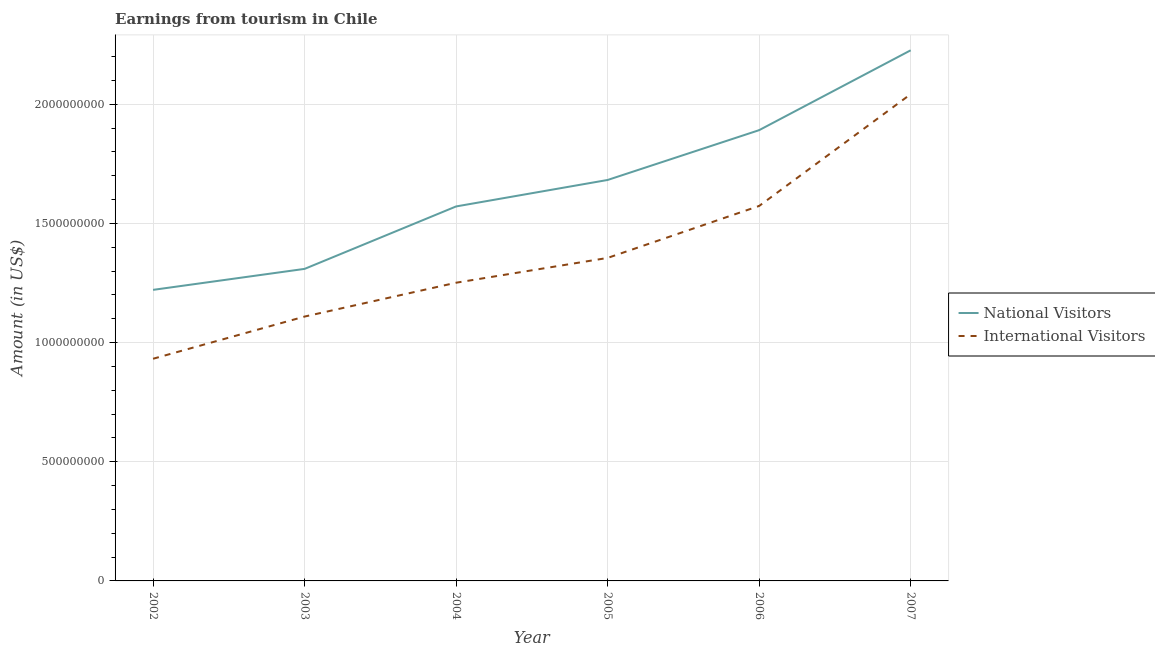Is the number of lines equal to the number of legend labels?
Your answer should be compact. Yes. What is the amount earned from national visitors in 2006?
Ensure brevity in your answer.  1.89e+09. Across all years, what is the maximum amount earned from international visitors?
Keep it short and to the point. 2.04e+09. Across all years, what is the minimum amount earned from national visitors?
Your response must be concise. 1.22e+09. In which year was the amount earned from national visitors minimum?
Make the answer very short. 2002. What is the total amount earned from international visitors in the graph?
Provide a succinct answer. 8.26e+09. What is the difference between the amount earned from national visitors in 2004 and that in 2005?
Offer a terse response. -1.11e+08. What is the difference between the amount earned from national visitors in 2006 and the amount earned from international visitors in 2005?
Provide a short and direct response. 5.36e+08. What is the average amount earned from international visitors per year?
Keep it short and to the point. 1.38e+09. In the year 2005, what is the difference between the amount earned from national visitors and amount earned from international visitors?
Your response must be concise. 3.27e+08. In how many years, is the amount earned from national visitors greater than 300000000 US$?
Make the answer very short. 6. What is the ratio of the amount earned from national visitors in 2002 to that in 2003?
Offer a very short reply. 0.93. What is the difference between the highest and the second highest amount earned from national visitors?
Your response must be concise. 3.35e+08. What is the difference between the highest and the lowest amount earned from international visitors?
Give a very brief answer. 1.11e+09. In how many years, is the amount earned from national visitors greater than the average amount earned from national visitors taken over all years?
Offer a very short reply. 3. How many years are there in the graph?
Provide a short and direct response. 6. Does the graph contain any zero values?
Give a very brief answer. No. What is the title of the graph?
Offer a terse response. Earnings from tourism in Chile. What is the Amount (in US$) in National Visitors in 2002?
Keep it short and to the point. 1.22e+09. What is the Amount (in US$) in International Visitors in 2002?
Offer a terse response. 9.32e+08. What is the Amount (in US$) of National Visitors in 2003?
Keep it short and to the point. 1.31e+09. What is the Amount (in US$) in International Visitors in 2003?
Offer a very short reply. 1.11e+09. What is the Amount (in US$) in National Visitors in 2004?
Ensure brevity in your answer.  1.57e+09. What is the Amount (in US$) of International Visitors in 2004?
Offer a very short reply. 1.25e+09. What is the Amount (in US$) in National Visitors in 2005?
Keep it short and to the point. 1.68e+09. What is the Amount (in US$) of International Visitors in 2005?
Offer a terse response. 1.36e+09. What is the Amount (in US$) of National Visitors in 2006?
Offer a very short reply. 1.89e+09. What is the Amount (in US$) of International Visitors in 2006?
Your answer should be compact. 1.57e+09. What is the Amount (in US$) of National Visitors in 2007?
Your response must be concise. 2.23e+09. What is the Amount (in US$) of International Visitors in 2007?
Offer a terse response. 2.04e+09. Across all years, what is the maximum Amount (in US$) in National Visitors?
Provide a succinct answer. 2.23e+09. Across all years, what is the maximum Amount (in US$) in International Visitors?
Provide a succinct answer. 2.04e+09. Across all years, what is the minimum Amount (in US$) in National Visitors?
Keep it short and to the point. 1.22e+09. Across all years, what is the minimum Amount (in US$) of International Visitors?
Ensure brevity in your answer.  9.32e+08. What is the total Amount (in US$) in National Visitors in the graph?
Make the answer very short. 9.90e+09. What is the total Amount (in US$) in International Visitors in the graph?
Provide a succinct answer. 8.26e+09. What is the difference between the Amount (in US$) of National Visitors in 2002 and that in 2003?
Your response must be concise. -8.80e+07. What is the difference between the Amount (in US$) in International Visitors in 2002 and that in 2003?
Offer a terse response. -1.77e+08. What is the difference between the Amount (in US$) of National Visitors in 2002 and that in 2004?
Your answer should be compact. -3.50e+08. What is the difference between the Amount (in US$) in International Visitors in 2002 and that in 2004?
Your answer should be compact. -3.19e+08. What is the difference between the Amount (in US$) in National Visitors in 2002 and that in 2005?
Give a very brief answer. -4.61e+08. What is the difference between the Amount (in US$) of International Visitors in 2002 and that in 2005?
Offer a terse response. -4.23e+08. What is the difference between the Amount (in US$) in National Visitors in 2002 and that in 2006?
Your answer should be very brief. -6.70e+08. What is the difference between the Amount (in US$) of International Visitors in 2002 and that in 2006?
Ensure brevity in your answer.  -6.41e+08. What is the difference between the Amount (in US$) of National Visitors in 2002 and that in 2007?
Provide a succinct answer. -1.00e+09. What is the difference between the Amount (in US$) in International Visitors in 2002 and that in 2007?
Your answer should be very brief. -1.11e+09. What is the difference between the Amount (in US$) in National Visitors in 2003 and that in 2004?
Ensure brevity in your answer.  -2.62e+08. What is the difference between the Amount (in US$) in International Visitors in 2003 and that in 2004?
Keep it short and to the point. -1.42e+08. What is the difference between the Amount (in US$) in National Visitors in 2003 and that in 2005?
Your answer should be compact. -3.73e+08. What is the difference between the Amount (in US$) of International Visitors in 2003 and that in 2005?
Keep it short and to the point. -2.46e+08. What is the difference between the Amount (in US$) in National Visitors in 2003 and that in 2006?
Keep it short and to the point. -5.82e+08. What is the difference between the Amount (in US$) in International Visitors in 2003 and that in 2006?
Your answer should be compact. -4.64e+08. What is the difference between the Amount (in US$) in National Visitors in 2003 and that in 2007?
Give a very brief answer. -9.17e+08. What is the difference between the Amount (in US$) in International Visitors in 2003 and that in 2007?
Ensure brevity in your answer.  -9.33e+08. What is the difference between the Amount (in US$) of National Visitors in 2004 and that in 2005?
Make the answer very short. -1.11e+08. What is the difference between the Amount (in US$) in International Visitors in 2004 and that in 2005?
Your answer should be very brief. -1.04e+08. What is the difference between the Amount (in US$) of National Visitors in 2004 and that in 2006?
Your response must be concise. -3.20e+08. What is the difference between the Amount (in US$) of International Visitors in 2004 and that in 2006?
Your answer should be compact. -3.22e+08. What is the difference between the Amount (in US$) in National Visitors in 2004 and that in 2007?
Keep it short and to the point. -6.55e+08. What is the difference between the Amount (in US$) in International Visitors in 2004 and that in 2007?
Your answer should be very brief. -7.91e+08. What is the difference between the Amount (in US$) in National Visitors in 2005 and that in 2006?
Your answer should be very brief. -2.09e+08. What is the difference between the Amount (in US$) of International Visitors in 2005 and that in 2006?
Offer a terse response. -2.18e+08. What is the difference between the Amount (in US$) in National Visitors in 2005 and that in 2007?
Your answer should be compact. -5.44e+08. What is the difference between the Amount (in US$) of International Visitors in 2005 and that in 2007?
Keep it short and to the point. -6.87e+08. What is the difference between the Amount (in US$) in National Visitors in 2006 and that in 2007?
Give a very brief answer. -3.35e+08. What is the difference between the Amount (in US$) of International Visitors in 2006 and that in 2007?
Your response must be concise. -4.69e+08. What is the difference between the Amount (in US$) in National Visitors in 2002 and the Amount (in US$) in International Visitors in 2003?
Offer a terse response. 1.12e+08. What is the difference between the Amount (in US$) in National Visitors in 2002 and the Amount (in US$) in International Visitors in 2004?
Your response must be concise. -3.00e+07. What is the difference between the Amount (in US$) in National Visitors in 2002 and the Amount (in US$) in International Visitors in 2005?
Ensure brevity in your answer.  -1.34e+08. What is the difference between the Amount (in US$) of National Visitors in 2002 and the Amount (in US$) of International Visitors in 2006?
Provide a short and direct response. -3.52e+08. What is the difference between the Amount (in US$) in National Visitors in 2002 and the Amount (in US$) in International Visitors in 2007?
Ensure brevity in your answer.  -8.21e+08. What is the difference between the Amount (in US$) in National Visitors in 2003 and the Amount (in US$) in International Visitors in 2004?
Offer a terse response. 5.80e+07. What is the difference between the Amount (in US$) of National Visitors in 2003 and the Amount (in US$) of International Visitors in 2005?
Make the answer very short. -4.60e+07. What is the difference between the Amount (in US$) of National Visitors in 2003 and the Amount (in US$) of International Visitors in 2006?
Offer a terse response. -2.64e+08. What is the difference between the Amount (in US$) of National Visitors in 2003 and the Amount (in US$) of International Visitors in 2007?
Make the answer very short. -7.33e+08. What is the difference between the Amount (in US$) of National Visitors in 2004 and the Amount (in US$) of International Visitors in 2005?
Ensure brevity in your answer.  2.16e+08. What is the difference between the Amount (in US$) of National Visitors in 2004 and the Amount (in US$) of International Visitors in 2007?
Provide a succinct answer. -4.71e+08. What is the difference between the Amount (in US$) of National Visitors in 2005 and the Amount (in US$) of International Visitors in 2006?
Give a very brief answer. 1.09e+08. What is the difference between the Amount (in US$) of National Visitors in 2005 and the Amount (in US$) of International Visitors in 2007?
Give a very brief answer. -3.60e+08. What is the difference between the Amount (in US$) in National Visitors in 2006 and the Amount (in US$) in International Visitors in 2007?
Your answer should be very brief. -1.51e+08. What is the average Amount (in US$) of National Visitors per year?
Keep it short and to the point. 1.65e+09. What is the average Amount (in US$) of International Visitors per year?
Your answer should be very brief. 1.38e+09. In the year 2002, what is the difference between the Amount (in US$) in National Visitors and Amount (in US$) in International Visitors?
Offer a terse response. 2.89e+08. In the year 2004, what is the difference between the Amount (in US$) in National Visitors and Amount (in US$) in International Visitors?
Provide a short and direct response. 3.20e+08. In the year 2005, what is the difference between the Amount (in US$) in National Visitors and Amount (in US$) in International Visitors?
Give a very brief answer. 3.27e+08. In the year 2006, what is the difference between the Amount (in US$) in National Visitors and Amount (in US$) in International Visitors?
Ensure brevity in your answer.  3.18e+08. In the year 2007, what is the difference between the Amount (in US$) of National Visitors and Amount (in US$) of International Visitors?
Your answer should be compact. 1.84e+08. What is the ratio of the Amount (in US$) in National Visitors in 2002 to that in 2003?
Provide a short and direct response. 0.93. What is the ratio of the Amount (in US$) of International Visitors in 2002 to that in 2003?
Make the answer very short. 0.84. What is the ratio of the Amount (in US$) of National Visitors in 2002 to that in 2004?
Your answer should be compact. 0.78. What is the ratio of the Amount (in US$) in International Visitors in 2002 to that in 2004?
Provide a short and direct response. 0.74. What is the ratio of the Amount (in US$) of National Visitors in 2002 to that in 2005?
Keep it short and to the point. 0.73. What is the ratio of the Amount (in US$) of International Visitors in 2002 to that in 2005?
Make the answer very short. 0.69. What is the ratio of the Amount (in US$) of National Visitors in 2002 to that in 2006?
Your answer should be very brief. 0.65. What is the ratio of the Amount (in US$) in International Visitors in 2002 to that in 2006?
Your answer should be compact. 0.59. What is the ratio of the Amount (in US$) in National Visitors in 2002 to that in 2007?
Make the answer very short. 0.55. What is the ratio of the Amount (in US$) in International Visitors in 2002 to that in 2007?
Keep it short and to the point. 0.46. What is the ratio of the Amount (in US$) of National Visitors in 2003 to that in 2004?
Make the answer very short. 0.83. What is the ratio of the Amount (in US$) in International Visitors in 2003 to that in 2004?
Provide a short and direct response. 0.89. What is the ratio of the Amount (in US$) of National Visitors in 2003 to that in 2005?
Your answer should be compact. 0.78. What is the ratio of the Amount (in US$) in International Visitors in 2003 to that in 2005?
Provide a short and direct response. 0.82. What is the ratio of the Amount (in US$) in National Visitors in 2003 to that in 2006?
Keep it short and to the point. 0.69. What is the ratio of the Amount (in US$) in International Visitors in 2003 to that in 2006?
Give a very brief answer. 0.7. What is the ratio of the Amount (in US$) of National Visitors in 2003 to that in 2007?
Your response must be concise. 0.59. What is the ratio of the Amount (in US$) of International Visitors in 2003 to that in 2007?
Your answer should be compact. 0.54. What is the ratio of the Amount (in US$) in National Visitors in 2004 to that in 2005?
Your response must be concise. 0.93. What is the ratio of the Amount (in US$) in International Visitors in 2004 to that in 2005?
Offer a terse response. 0.92. What is the ratio of the Amount (in US$) of National Visitors in 2004 to that in 2006?
Your answer should be very brief. 0.83. What is the ratio of the Amount (in US$) in International Visitors in 2004 to that in 2006?
Make the answer very short. 0.8. What is the ratio of the Amount (in US$) of National Visitors in 2004 to that in 2007?
Ensure brevity in your answer.  0.71. What is the ratio of the Amount (in US$) in International Visitors in 2004 to that in 2007?
Provide a short and direct response. 0.61. What is the ratio of the Amount (in US$) in National Visitors in 2005 to that in 2006?
Ensure brevity in your answer.  0.89. What is the ratio of the Amount (in US$) of International Visitors in 2005 to that in 2006?
Your answer should be very brief. 0.86. What is the ratio of the Amount (in US$) in National Visitors in 2005 to that in 2007?
Keep it short and to the point. 0.76. What is the ratio of the Amount (in US$) in International Visitors in 2005 to that in 2007?
Provide a short and direct response. 0.66. What is the ratio of the Amount (in US$) in National Visitors in 2006 to that in 2007?
Provide a short and direct response. 0.85. What is the ratio of the Amount (in US$) in International Visitors in 2006 to that in 2007?
Offer a terse response. 0.77. What is the difference between the highest and the second highest Amount (in US$) of National Visitors?
Provide a short and direct response. 3.35e+08. What is the difference between the highest and the second highest Amount (in US$) of International Visitors?
Your answer should be very brief. 4.69e+08. What is the difference between the highest and the lowest Amount (in US$) of National Visitors?
Your answer should be very brief. 1.00e+09. What is the difference between the highest and the lowest Amount (in US$) of International Visitors?
Give a very brief answer. 1.11e+09. 